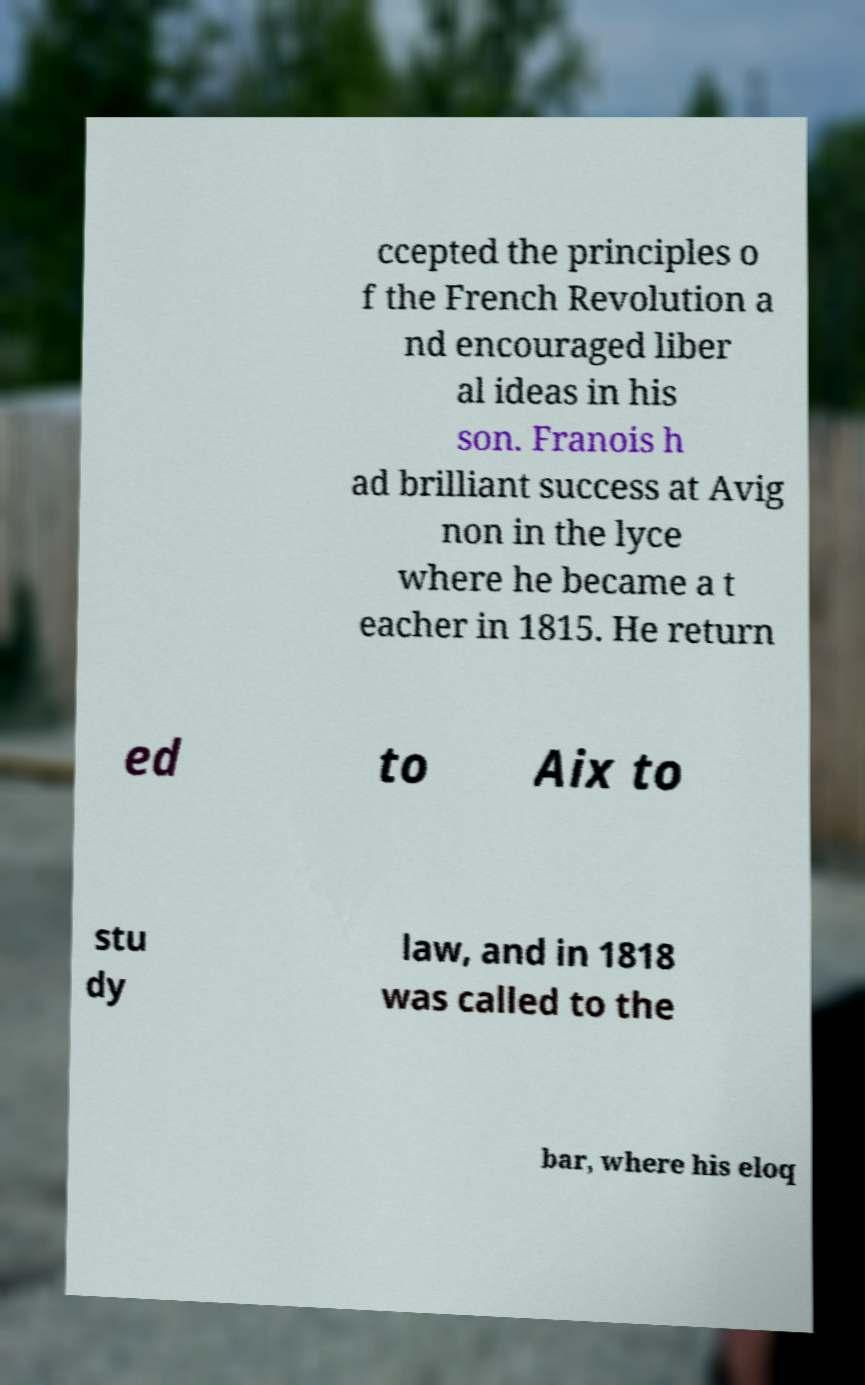Please read and relay the text visible in this image. What does it say? ccepted the principles o f the French Revolution a nd encouraged liber al ideas in his son. Franois h ad brilliant success at Avig non in the lyce where he became a t eacher in 1815. He return ed to Aix to stu dy law, and in 1818 was called to the bar, where his eloq 